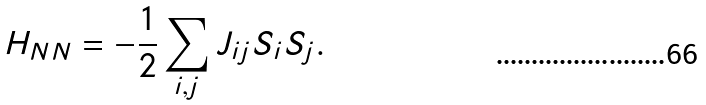<formula> <loc_0><loc_0><loc_500><loc_500>H _ { N N } = - \frac { 1 } { 2 } \sum _ { i , j } J _ { i j } S _ { i } S _ { j } .</formula> 